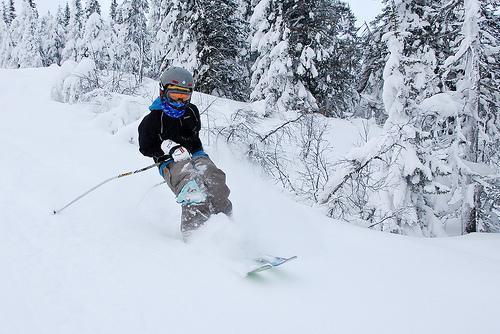How many people are there?
Give a very brief answer. 1. 